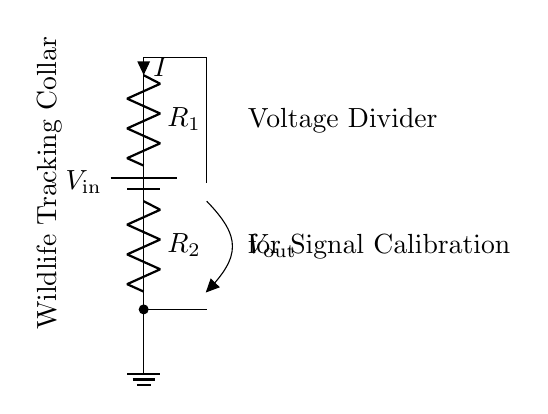What is the input voltage labeled as? The input voltage in the circuit is labeled as V_in, representing the voltage supplied to the circuit.
Answer: V_in What are the resistor values in the circuit? The circuit has two resistors labeled R_1 and R_2, indicating their presence though values for them are not provided.
Answer: R_1, R_2 What is the output voltage labeled as? The output voltage in the circuit is labeled as V_out, indicating the voltage measured across a specific point in the circuit.
Answer: V_out How does the current flow in the circuit? Current flows from the battery into resistor R_1, then through resistor R_2, following the closed circuit path.
Answer: From battery through R_1 to R_2 What is the purpose of the voltage divider in this context? The voltage divider is used to calibrate the signals from wildlife tracking collars, indicating its practical application in biodiversity studies.
Answer: Signal calibration If R_1 is doubled, what happens to V_out? Doubling the resistance R_1 would increase its voltage drop, resulting in a decrease in V_out because voltage dividers distribute the input voltage based on resistor ratios.
Answer: Decreases 